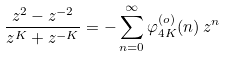<formula> <loc_0><loc_0><loc_500><loc_500>\frac { z ^ { 2 } - z ^ { - 2 } } { z ^ { K } + z ^ { - K } } = - \sum _ { n = 0 } ^ { \infty } \varphi _ { 4 K } ^ { ( o ) } ( n ) \, z ^ { n }</formula> 